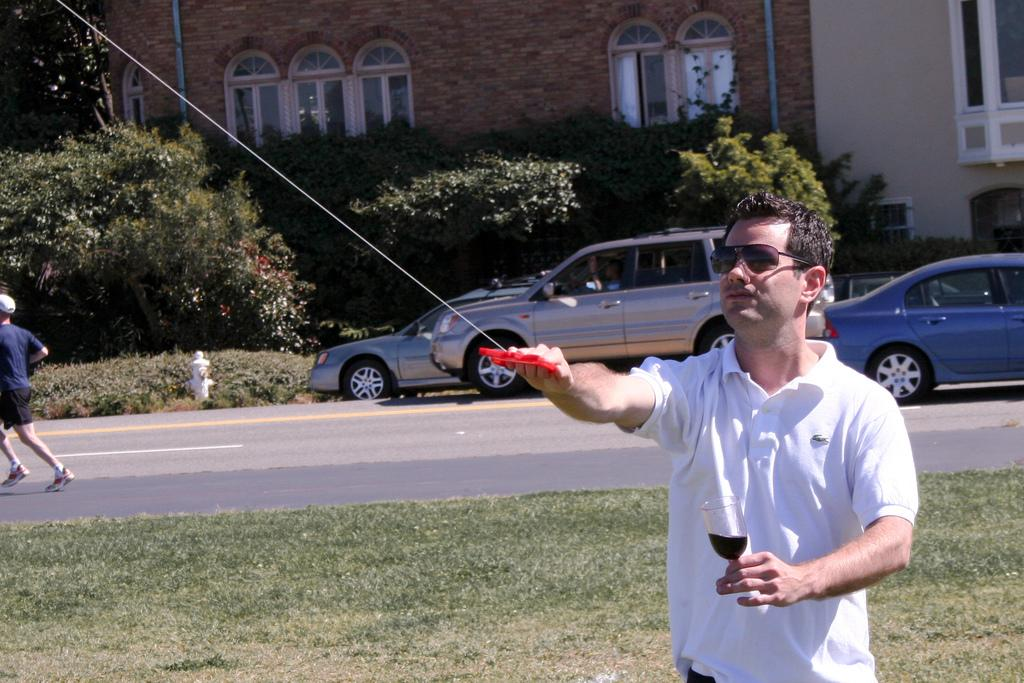What is the man wearing on his face in the image? The man is wearing goggles in the image. What is the man holding in his hand? The man is holding a glass in the image. What can be seen on the road in the image? There are vehicles on the road in the image. How is the man moving in the image? The man is running, as indicated by leg movement. What is visible in the distance in the image? There is a building with windows in the distance in the image. What type of vegetation is near the building? There are plants near the building in the image. What type of ship can be seen sailing near the building in the image? There is no ship visible in the image; it only features a man, vehicles, and a building with plants nearby. 